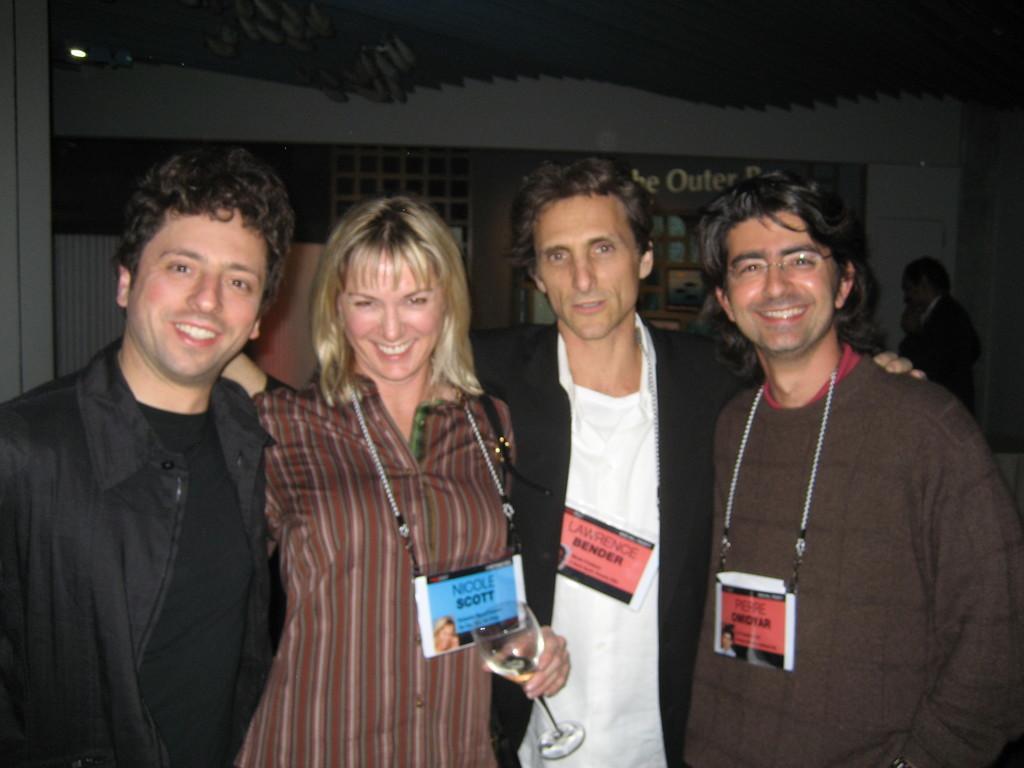In one or two sentences, can you explain what this image depicts? In this picture I can see four persons standing and smiling, there is a woman holding a wine glass, and in the background there is a person standing and there are some objects. 